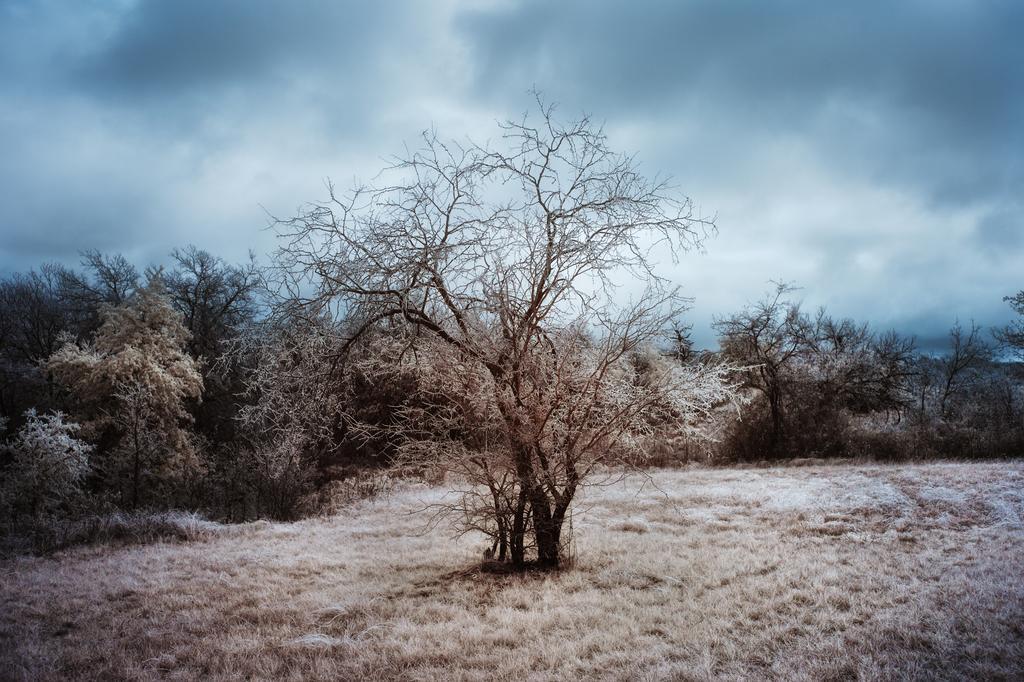Can you describe this image briefly? In the image I can see some dry trees and some dry grass on the ground. 